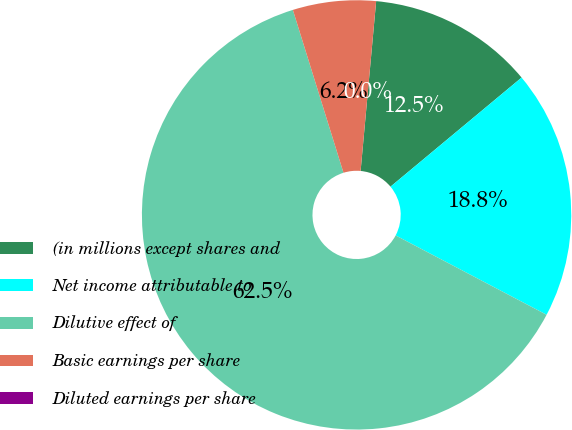Convert chart. <chart><loc_0><loc_0><loc_500><loc_500><pie_chart><fcel>(in millions except shares and<fcel>Net income attributable to<fcel>Dilutive effect of<fcel>Basic earnings per share<fcel>Diluted earnings per share<nl><fcel>12.5%<fcel>18.75%<fcel>62.5%<fcel>6.25%<fcel>0.0%<nl></chart> 